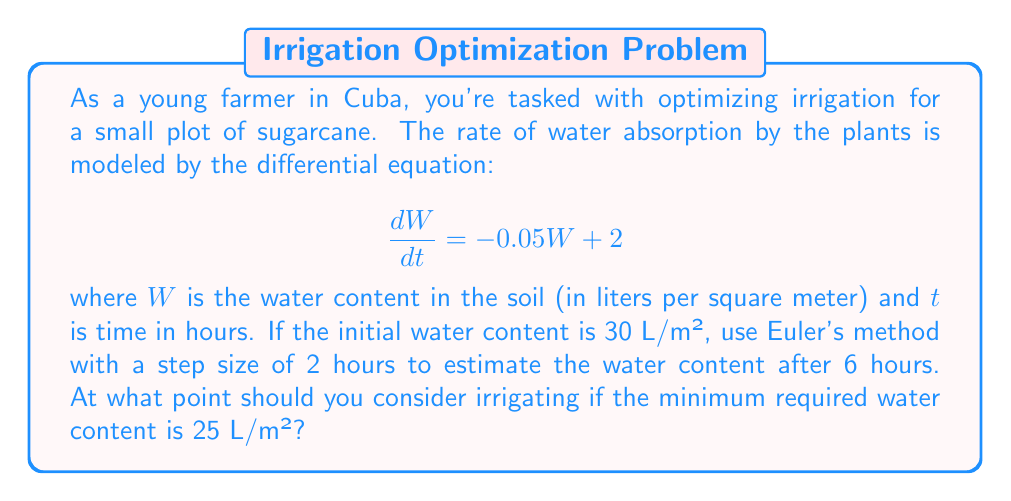What is the answer to this math problem? Let's solve this problem step by step using Euler's method:

1) Euler's method is given by the formula:
   $$W_{n+1} = W_n + h \cdot f(t_n, W_n)$$
   where $h$ is the step size, and $f(t, W) = \frac{dW}{dt} = -0.05W + 2$

2) We're given:
   - Initial water content $W_0 = 30$ L/m²
   - Step size $h = 2$ hours
   - We need to calculate for 6 hours, so we'll do 3 steps

3) Step 1 ($t = 0$ to $t = 2$):
   $$W_1 = 30 + 2 \cdot (-0.05 \cdot 30 + 2) = 30 + 2 \cdot 0.5 = 31$$ L/m²

4) Step 2 ($t = 2$ to $t = 4$):
   $$W_2 = 31 + 2 \cdot (-0.05 \cdot 31 + 2) = 31 + 2 \cdot 0.45 = 31.9$$ L/m²

5) Step 3 ($t = 4$ to $t = 6$):
   $$W_3 = 31.9 + 2 \cdot (-0.05 \cdot 31.9 + 2) = 31.9 + 2 \cdot 0.405 = 32.71$$ L/m²

6) After 6 hours, the estimated water content is 32.71 L/m².

7) To determine when to irrigate, we need to solve:
   $$25 = 30e^{-0.05t} + 40(1 - e^{-0.05t})$$
   
   This gives us $t \approx 22.14$ hours.

Therefore, you should consider irrigating after approximately 22 hours to maintain the minimum required water content of 25 L/m².
Answer: 32.71 L/m² after 6 hours; irrigate after 22 hours 